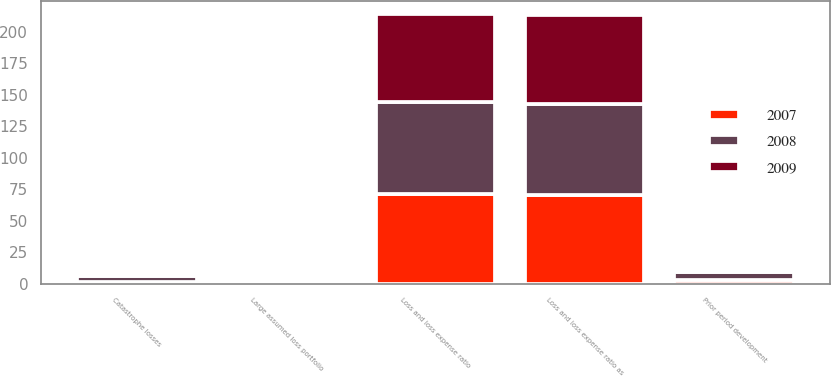Convert chart to OTSL. <chart><loc_0><loc_0><loc_500><loc_500><stacked_bar_chart><ecel><fcel>Loss and loss expense ratio as<fcel>Catastrophe losses<fcel>Prior period development<fcel>Large assumed loss portfolio<fcel>Loss and loss expense ratio<nl><fcel>2007<fcel>70.6<fcel>1<fcel>3.1<fcel>1.2<fcel>71.5<nl><fcel>2008<fcel>71.8<fcel>5.4<fcel>6.2<fcel>0<fcel>72.6<nl><fcel>2009<fcel>71.1<fcel>0.3<fcel>0.2<fcel>0.8<fcel>69.8<nl></chart> 